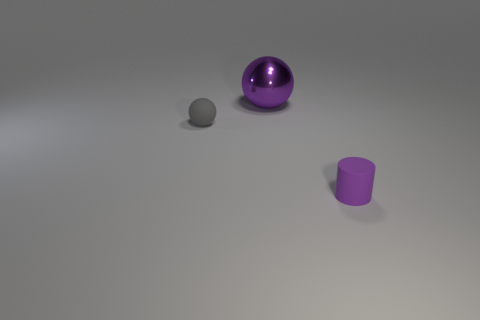How many other objects are the same material as the large purple thing?
Provide a succinct answer. 0. How many purple things are either tiny rubber spheres or cylinders?
Offer a very short reply. 1. There is a small thing that is in front of the gray matte sphere; is its shape the same as the tiny thing that is left of the purple matte cylinder?
Give a very brief answer. No. Do the small cylinder and the tiny thing that is to the left of the shiny thing have the same color?
Ensure brevity in your answer.  No. Do the object that is right of the large purple ball and the tiny sphere have the same color?
Your response must be concise. No. What number of things are either red metal things or matte objects that are right of the big purple object?
Keep it short and to the point. 1. What material is the thing that is both to the left of the purple cylinder and in front of the big object?
Your answer should be compact. Rubber. There is a small object on the right side of the gray matte ball; what is its material?
Keep it short and to the point. Rubber. There is a thing that is made of the same material as the tiny purple cylinder; what color is it?
Provide a succinct answer. Gray. There is a tiny purple rubber object; does it have the same shape as the object to the left of the metallic ball?
Offer a very short reply. No. 